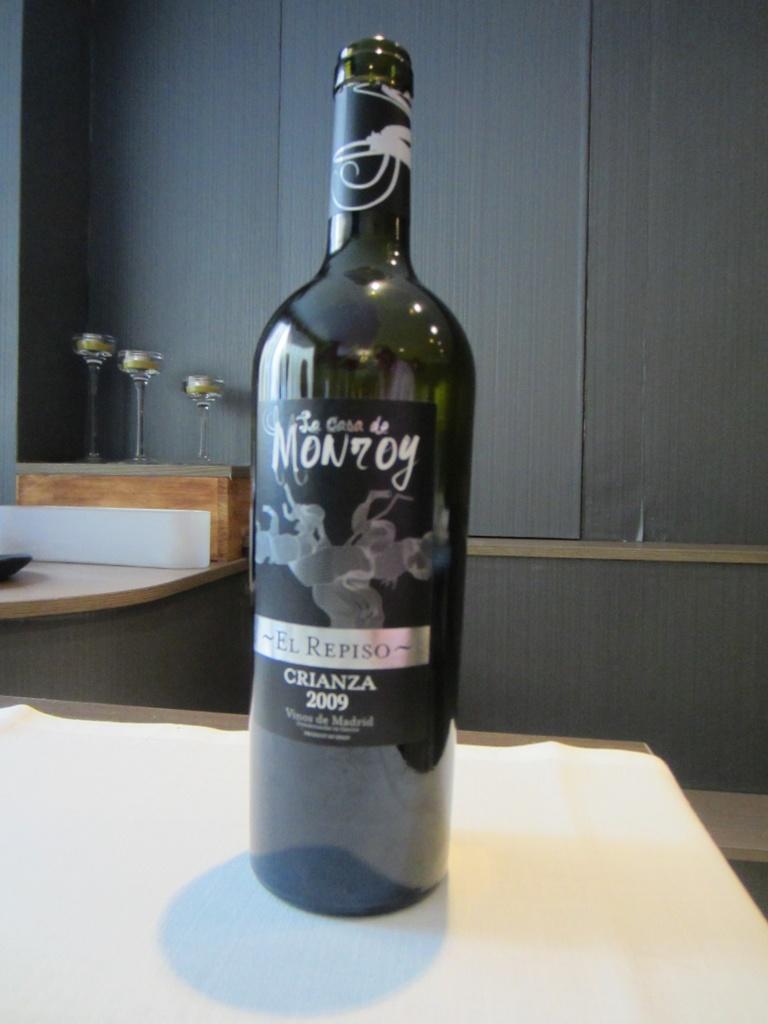Describe this image in one or two sentences. In this picture I can see there is a wine bottle placed on the wooden surface and there is a label on it. There are few wine glasses in the backdrop and there is a wooden wall. 